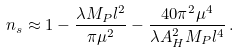<formula> <loc_0><loc_0><loc_500><loc_500>n _ { s } \approx 1 - \frac { \lambda M _ { P } l ^ { 2 } } { \pi \mu ^ { 2 } } - \frac { 4 0 \pi ^ { 2 } \mu ^ { 4 } } { \lambda A _ { H } ^ { 2 } M _ { P } l ^ { 4 } } \, .</formula> 